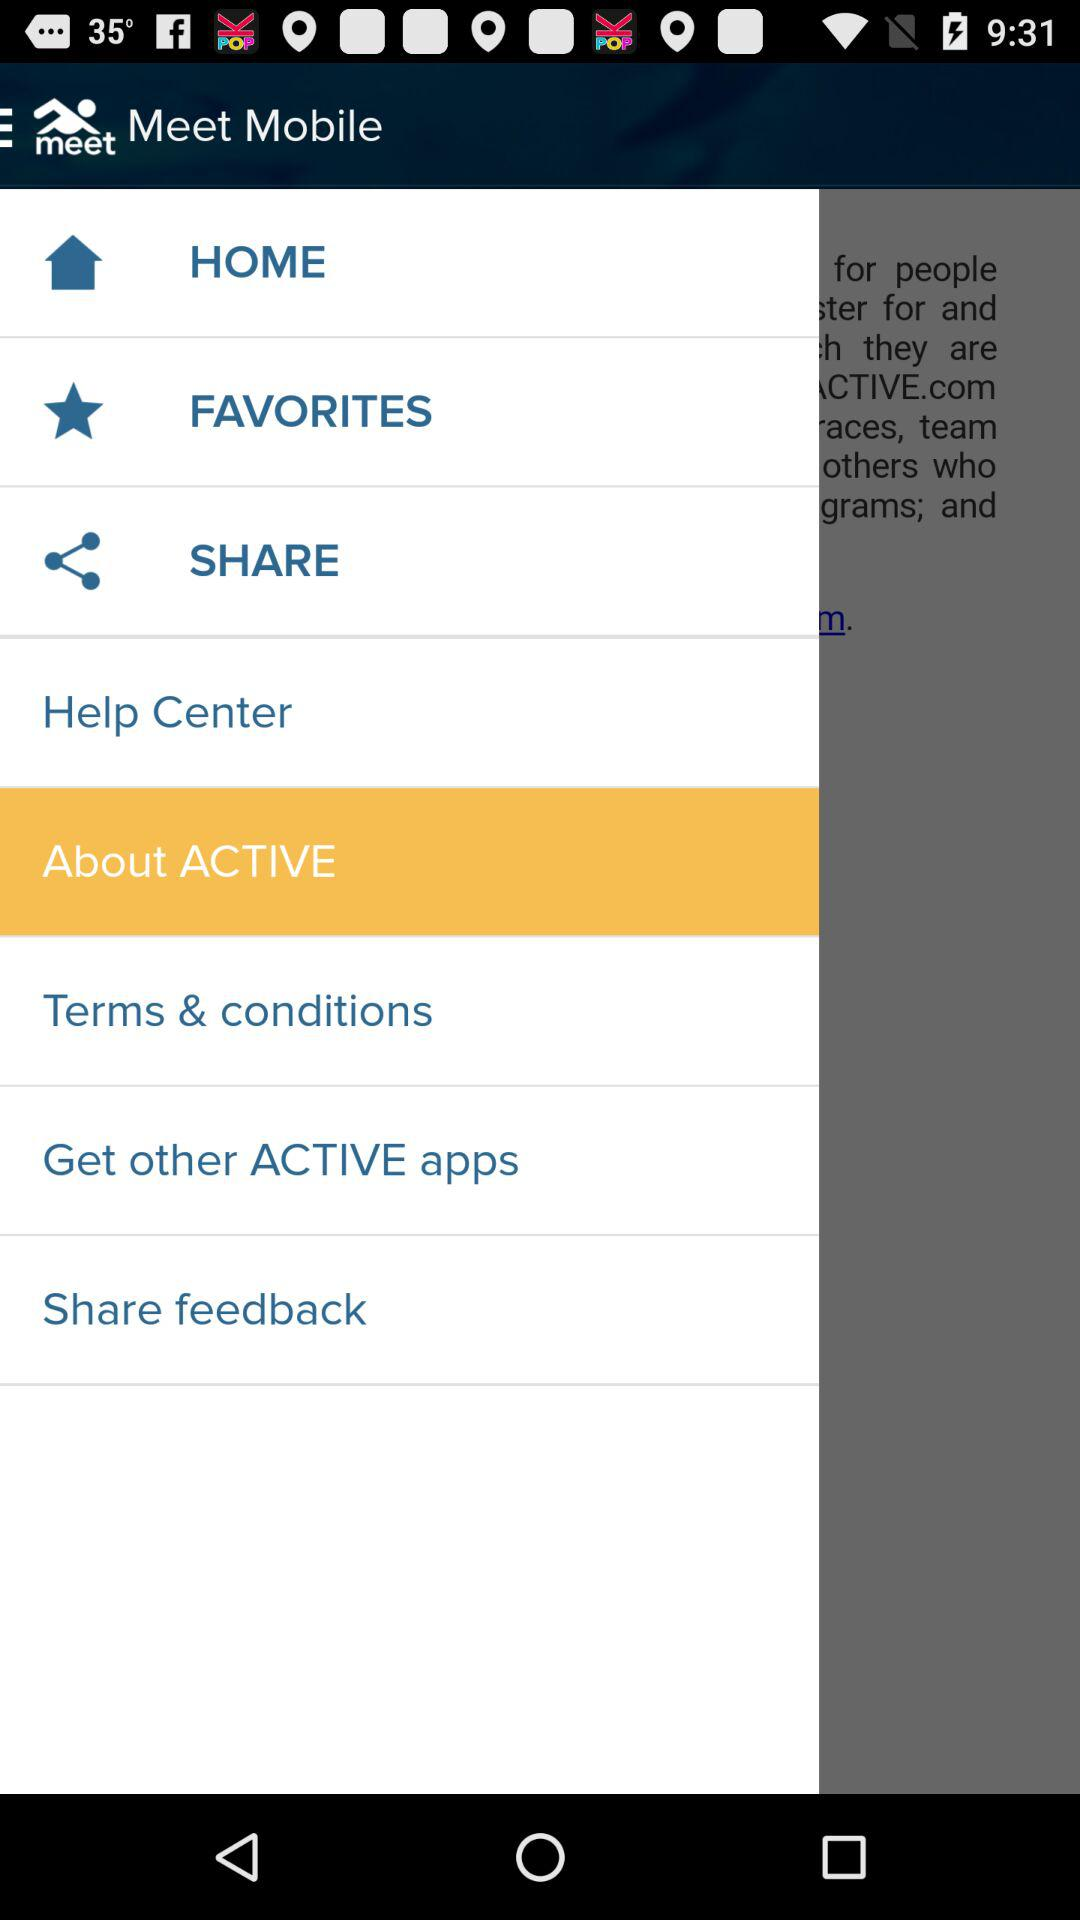Which is the selected item in the menu? The selected item is "About ACTIVE". 